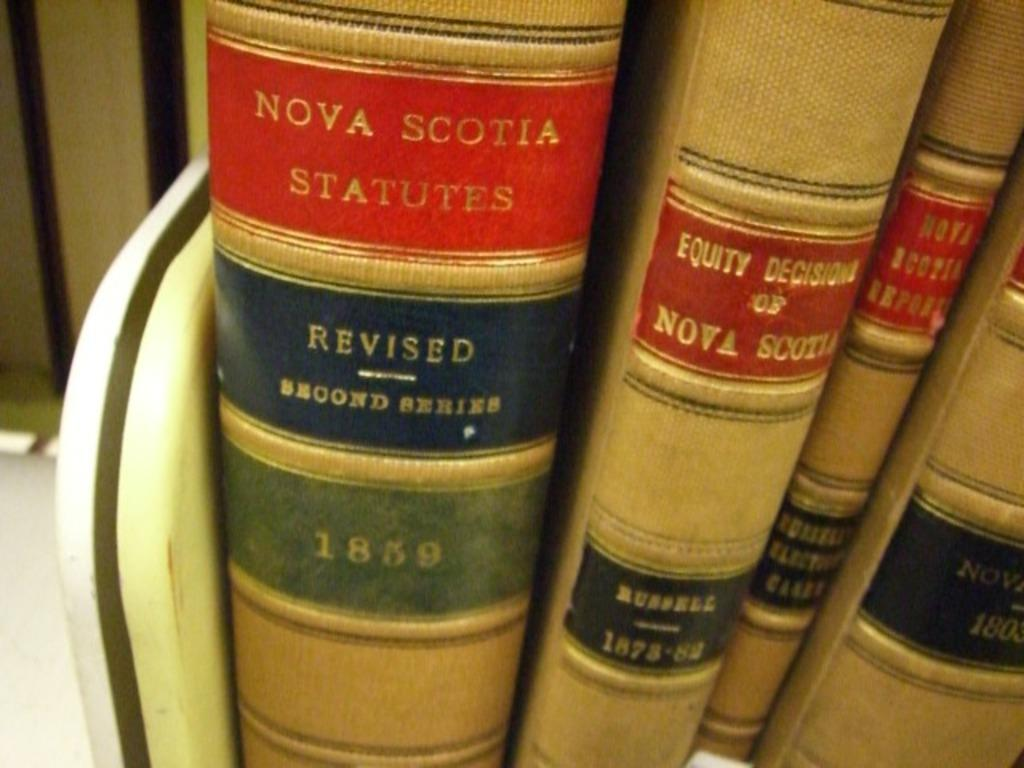<image>
Offer a succinct explanation of the picture presented. Several books on a shelf include the title NOVA SCOTIA STATUTES from 1859. 